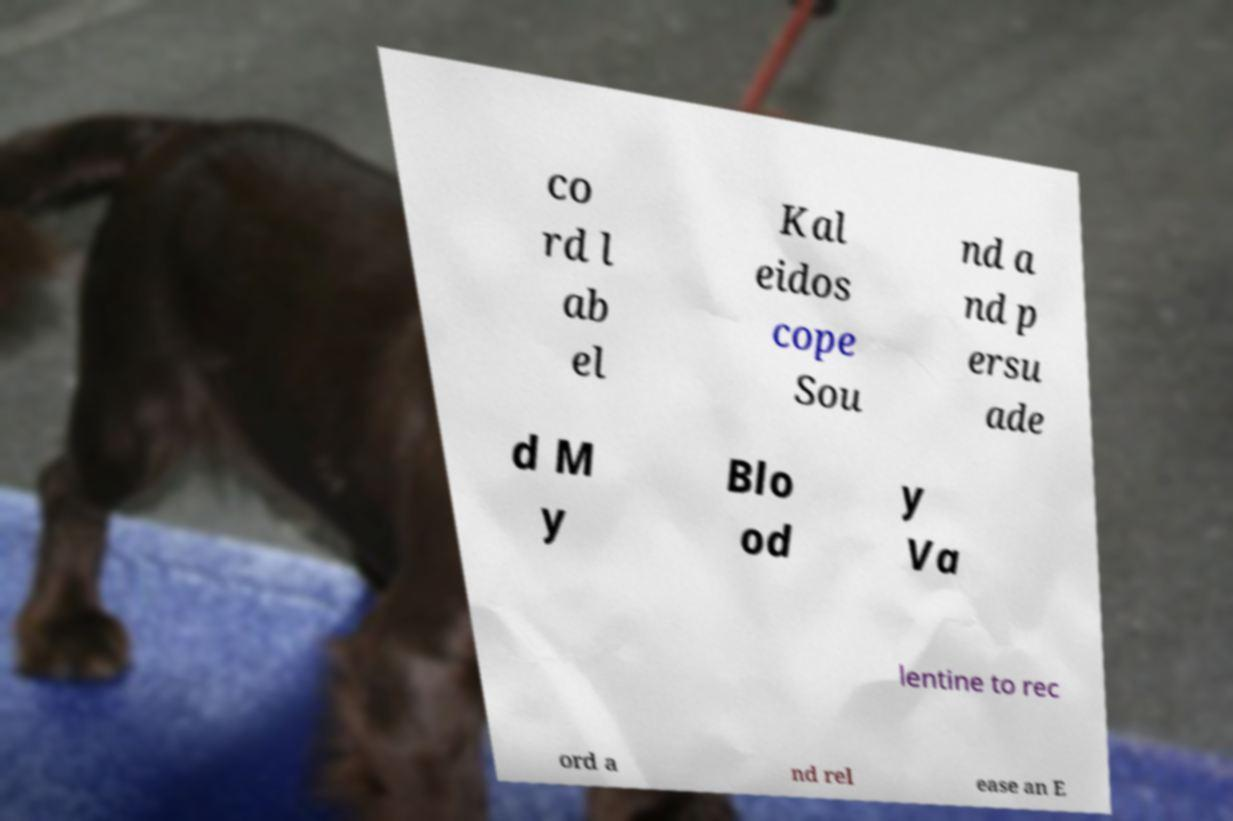There's text embedded in this image that I need extracted. Can you transcribe it verbatim? co rd l ab el Kal eidos cope Sou nd a nd p ersu ade d M y Blo od y Va lentine to rec ord a nd rel ease an E 